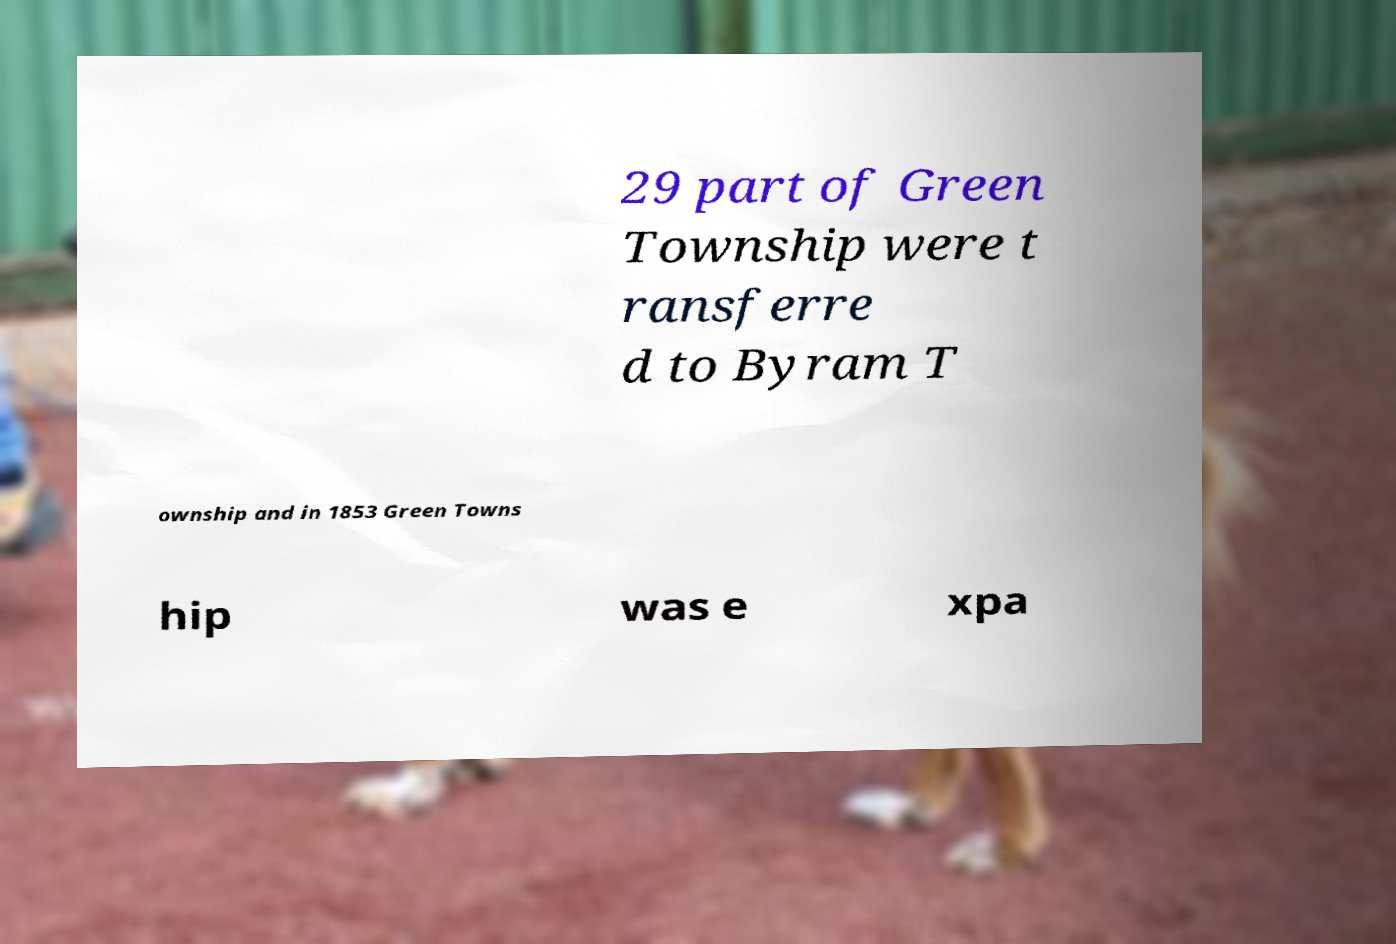Could you extract and type out the text from this image? 29 part of Green Township were t ransferre d to Byram T ownship and in 1853 Green Towns hip was e xpa 